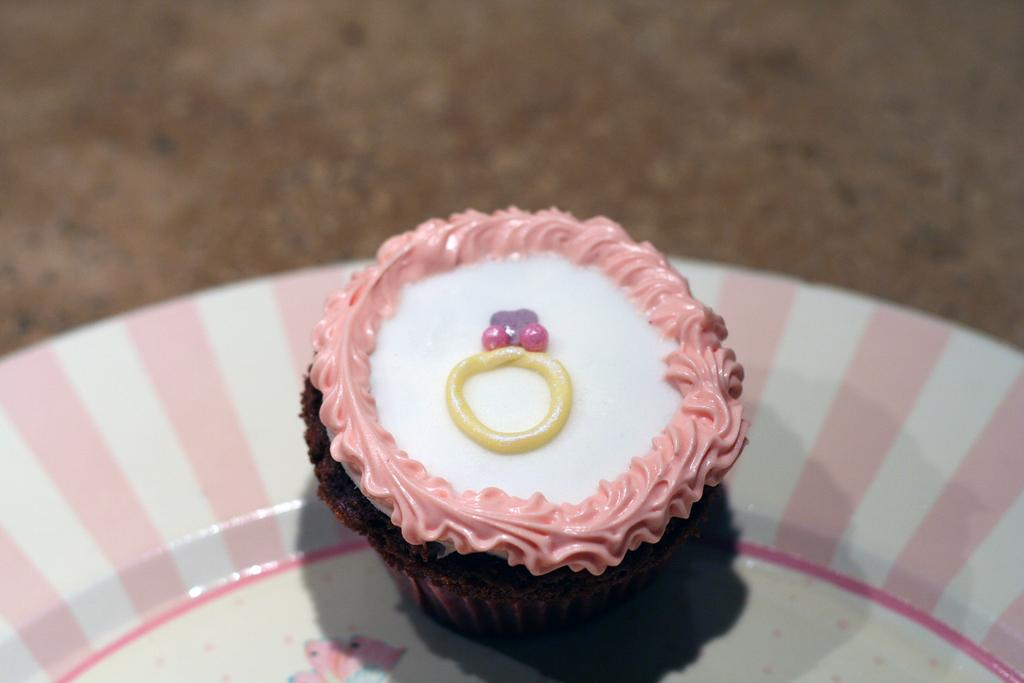What is on the plate in the image? There is a cupcake on the plate in the image. What can you tell me about the plate's appearance? The plate is white and pink in color. Where is the plate located in the image? The plate is on a brown surface. What colors can be seen on the cupcake? The cupcake is brown, white, pink, and yellow in color. Who is the manager of the baby in the image? There is no baby or manager present in the image; it only features a plate with a cupcake on it. 